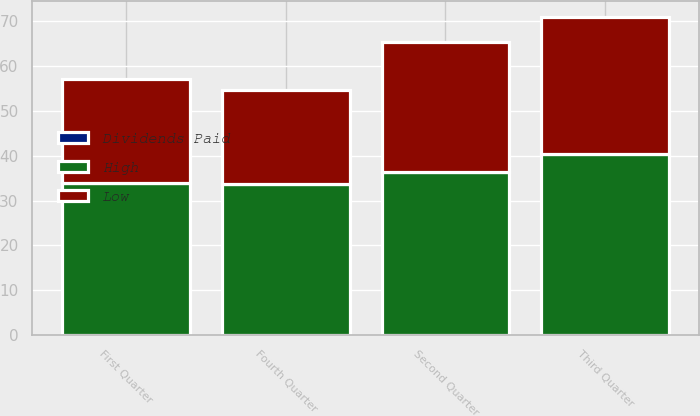Convert chart. <chart><loc_0><loc_0><loc_500><loc_500><stacked_bar_chart><ecel><fcel>First Quarter<fcel>Second Quarter<fcel>Third Quarter<fcel>Fourth Quarter<nl><fcel>Dividends Paid<fcel>0.1<fcel>0.1<fcel>0.1<fcel>0.1<nl><fcel>High<fcel>33.8<fcel>36.32<fcel>40.25<fcel>33.69<nl><fcel>Low<fcel>23.28<fcel>28.93<fcel>30.63<fcel>20.92<nl></chart> 